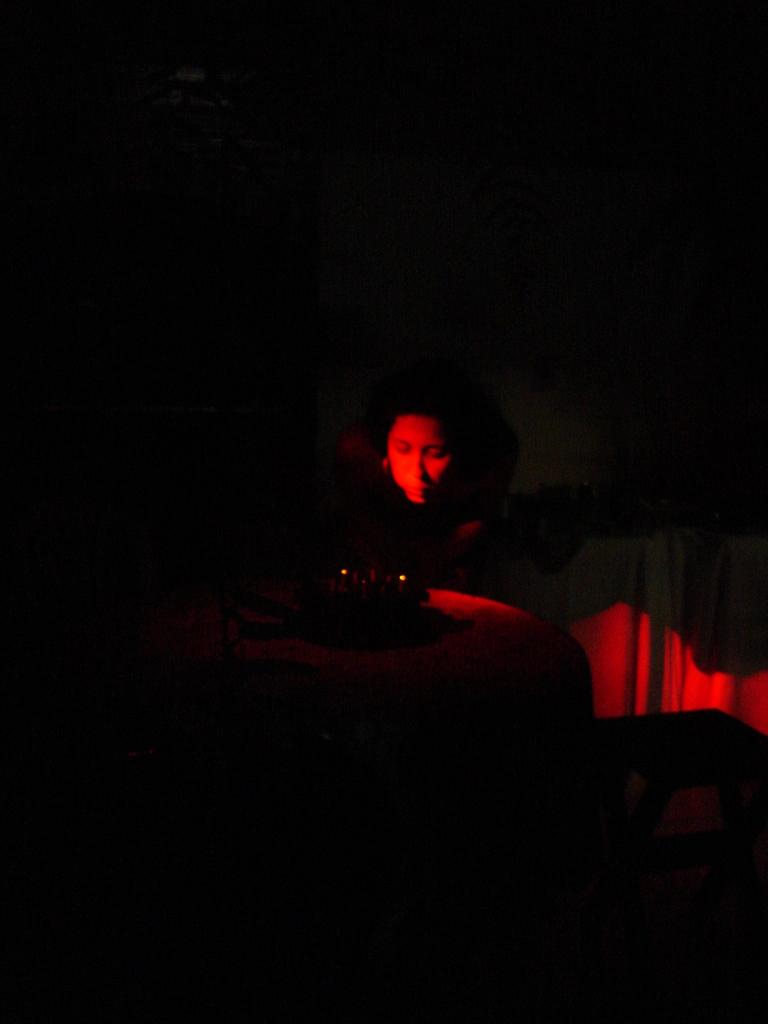What is the main subject of the image? There is a person's face in the image. Can you describe the background of the image? The background of the image is dark. What type of mine can be seen in the background of the image? There is no mine present in the image; the background is dark. What time of day is it in the image, considering the presence of wings? There are no wings present in the image, and therefore we cannot determine the time of day based on this information. 